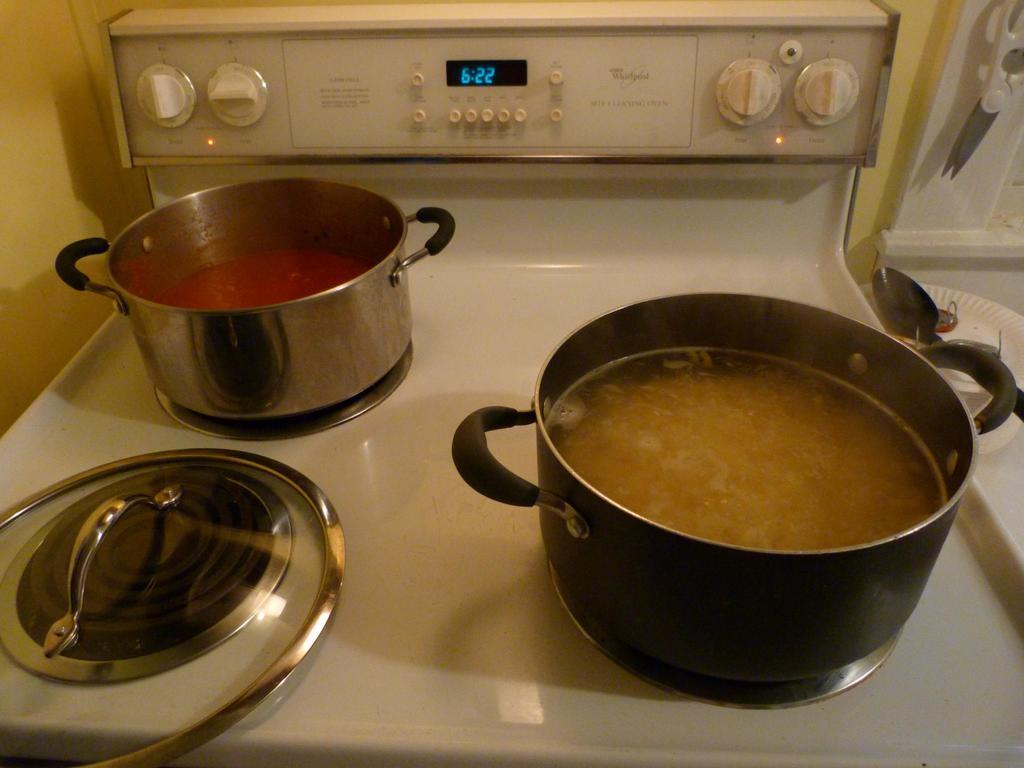<image>
Render a clear and concise summary of the photo. A stove with two pans on it lists the time as 6:22. 